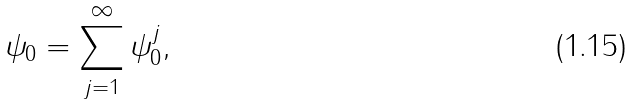<formula> <loc_0><loc_0><loc_500><loc_500>\psi _ { 0 } = \sum _ { j = 1 } ^ { \infty } \psi ^ { j } _ { 0 } ,</formula> 